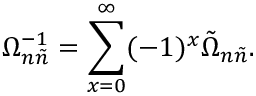Convert formula to latex. <formula><loc_0><loc_0><loc_500><loc_500>\Omega _ { n \tilde { n } } ^ { - 1 } = \sum _ { x = 0 } ^ { \infty } ( - 1 ) ^ { x } \tilde { \Omega } _ { n \tilde { n } } .</formula> 